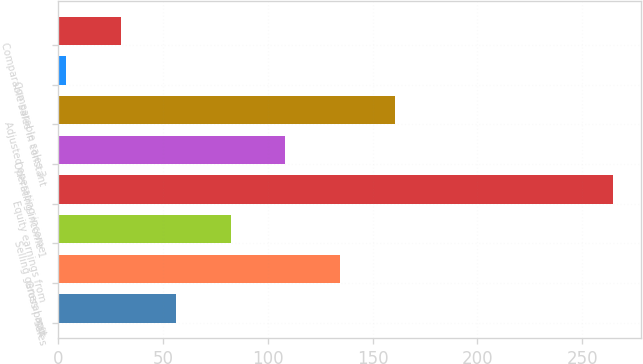<chart> <loc_0><loc_0><loc_500><loc_500><bar_chart><fcel>Sales<fcel>Gross profit<fcel>Selling general and<fcel>Equity earnings from<fcel>Operating income 1<fcel>Adjusted operating income<fcel>Comparable sales 3<fcel>Comparable sales in constant<nl><fcel>56.1<fcel>134.4<fcel>82.2<fcel>264.9<fcel>108.3<fcel>160.5<fcel>3.9<fcel>30<nl></chart> 